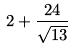<formula> <loc_0><loc_0><loc_500><loc_500>2 + \frac { 2 4 } { \sqrt { 1 3 } }</formula> 